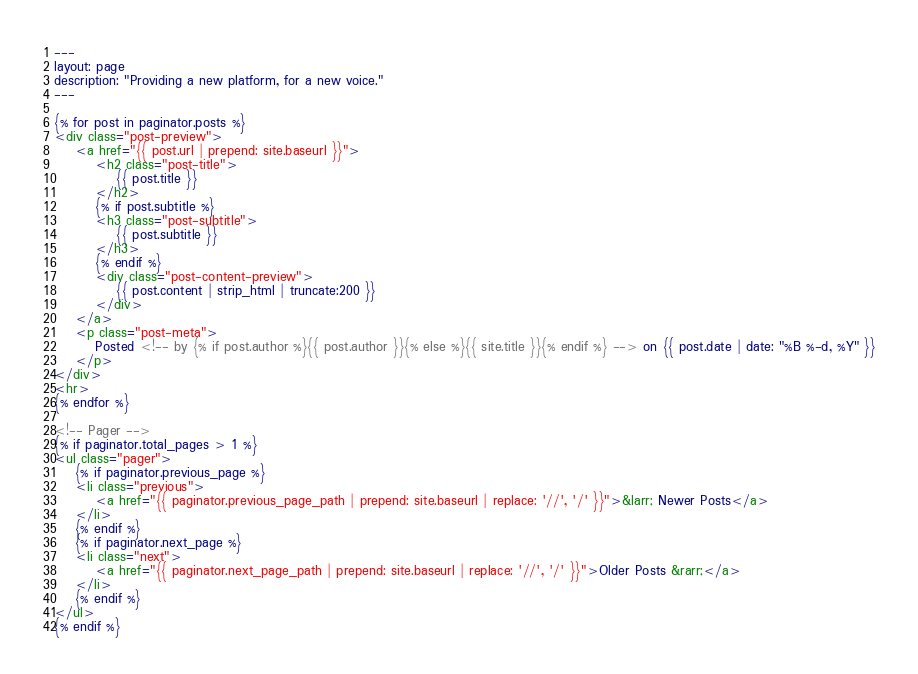<code> <loc_0><loc_0><loc_500><loc_500><_HTML_>---
layout: page
description: "Providing a new platform, for a new voice."
---

{% for post in paginator.posts %}
<div class="post-preview">
    <a href="{{ post.url | prepend: site.baseurl }}">
        <h2 class="post-title">
            {{ post.title }}
        </h2>
        {% if post.subtitle %}
        <h3 class="post-subtitle">
            {{ post.subtitle }}
        </h3>
        {% endif %}
        <div class="post-content-preview">
            {{ post.content | strip_html | truncate:200 }}
        </div>
    </a>
    <p class="post-meta">
        Posted <!-- by {% if post.author %}{{ post.author }}{% else %}{{ site.title }}{% endif %} --> on {{ post.date | date: "%B %-d, %Y" }}
    </p>
</div>
<hr>
{% endfor %}

<!-- Pager -->
{% if paginator.total_pages > 1 %}
<ul class="pager">
    {% if paginator.previous_page %}
    <li class="previous">
        <a href="{{ paginator.previous_page_path | prepend: site.baseurl | replace: '//', '/' }}">&larr; Newer Posts</a>
    </li>
    {% endif %}
    {% if paginator.next_page %}
    <li class="next">
        <a href="{{ paginator.next_page_path | prepend: site.baseurl | replace: '//', '/' }}">Older Posts &rarr;</a>
    </li>
    {% endif %}
</ul>
{% endif %}
</code> 